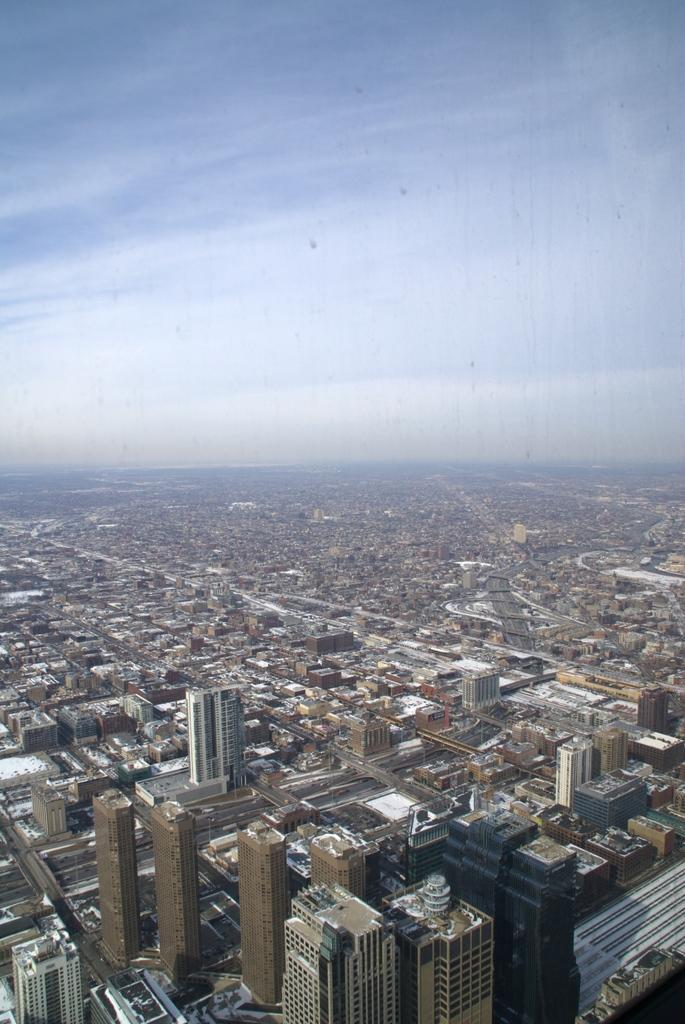What perspective is the image taken from? The image provides a top view of the city. What can be seen in the image from this perspective? There are many buildings visible in the image. What is visible at the top of the image? The sky is visible at the top of the image. What route is the attacker taking through the city in the image? There is no attacker or route present in the image; it shows a top view of the city with many buildings and the sky visible. 